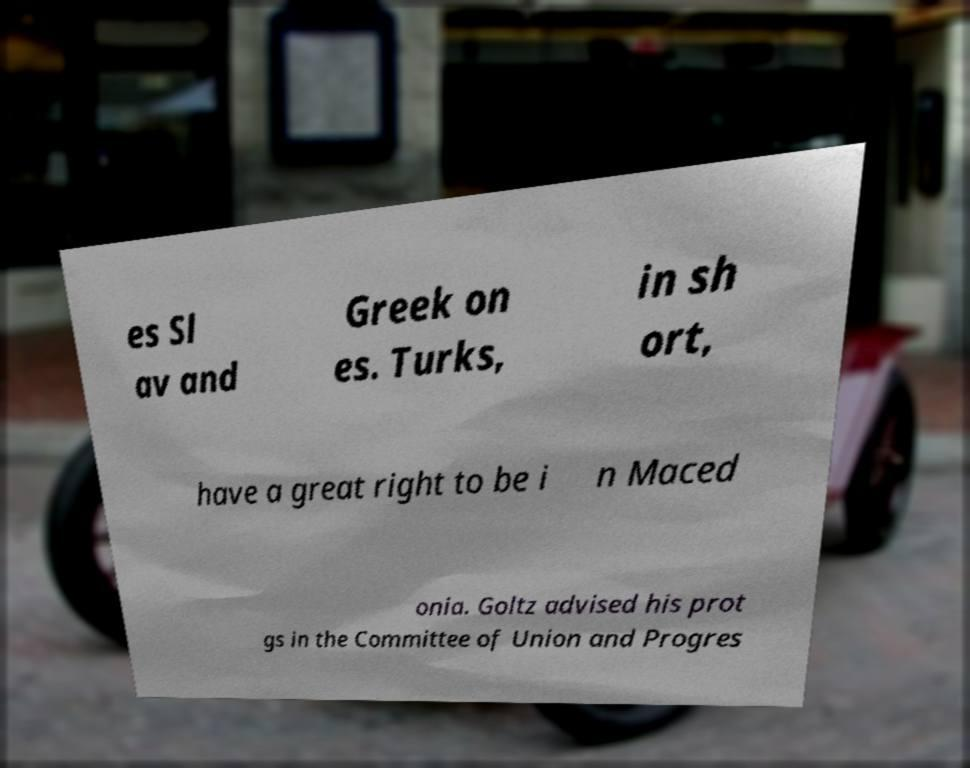Could you extract and type out the text from this image? es Sl av and Greek on es. Turks, in sh ort, have a great right to be i n Maced onia. Goltz advised his prot gs in the Committee of Union and Progres 